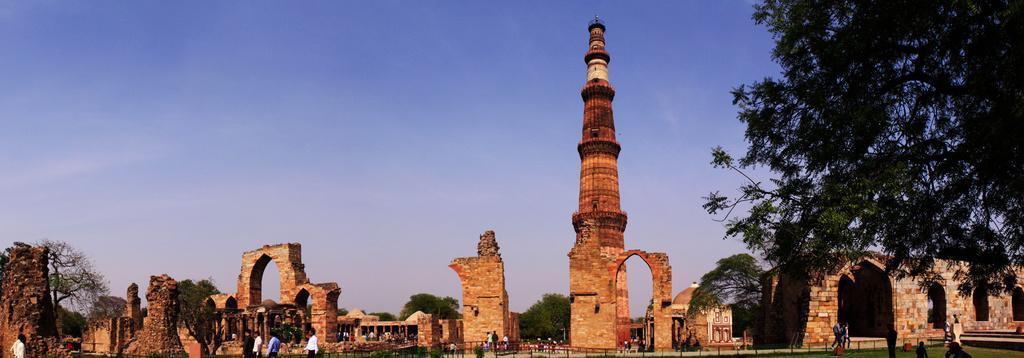Describe this image in one or two sentences. In this picture we can observe a tower. There are some walls and trees. We can observe some people walking. In the background there is a sky. 